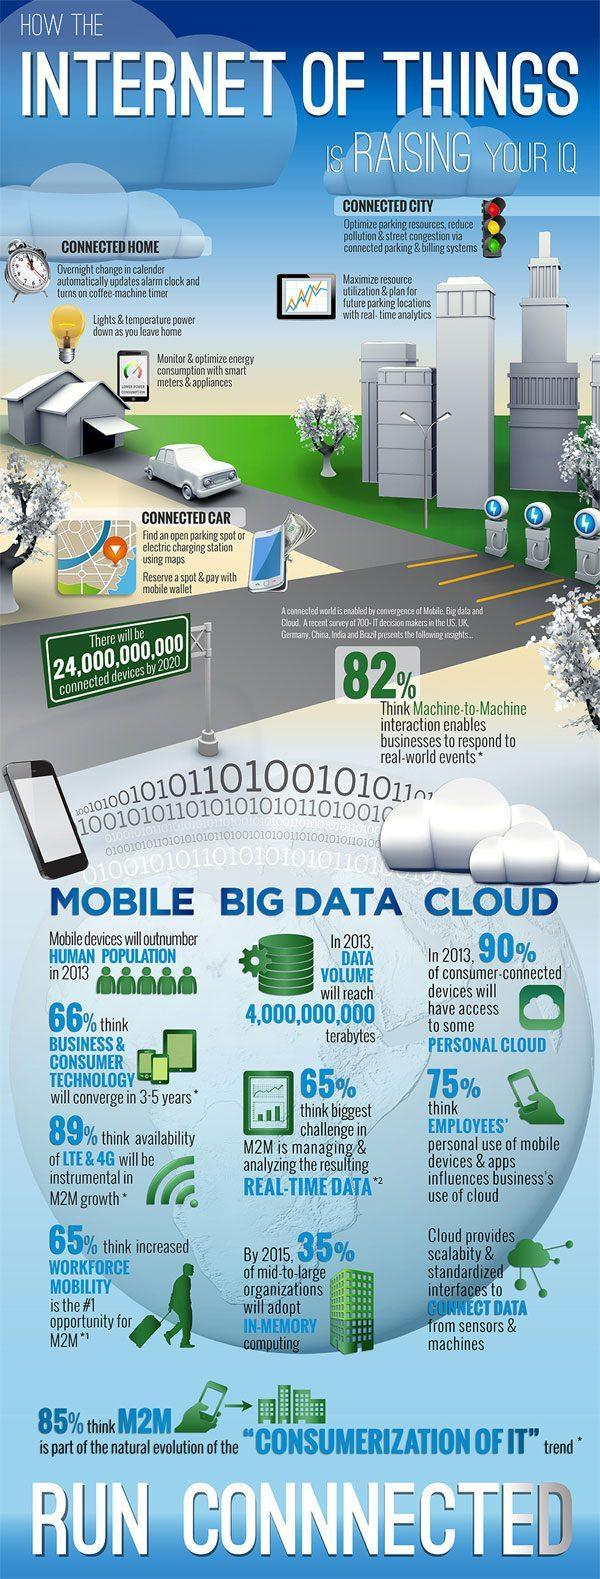What is the estimated data volume in 2013?
Answer the question with a short phrase. 4,000,000,000 terabytes What percentage of mid-to-large organizations will adopt in-memory computing by 2015? 35% What percentage of consumer connected devices will have access to some personal cloud in 2013? 90% What percentage of IT decision makers think that availability of LTE & 4G will be instrumental in M2M growth? 89% What percentage of IT decision makers think that managing & analyzing the resulting real-time data is the biggest challenge in M2M as per the survey? 65% 